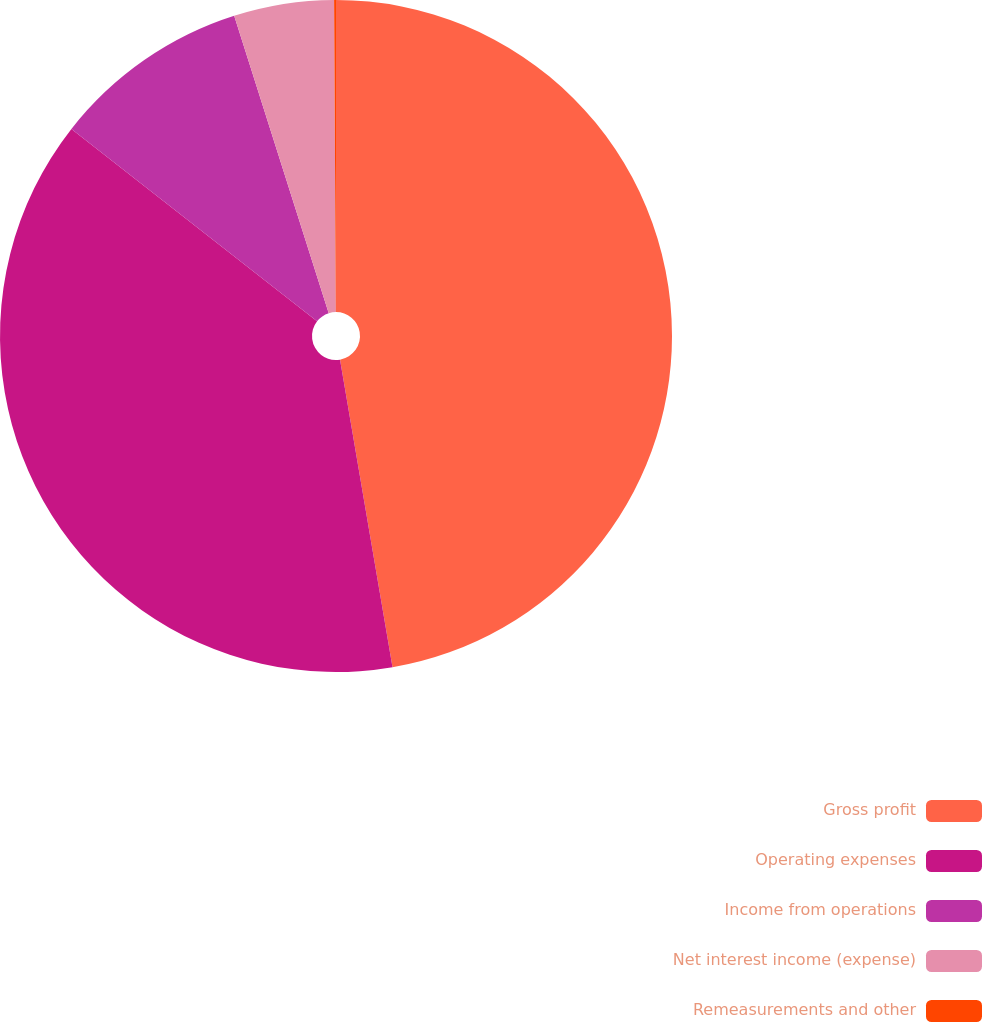<chart> <loc_0><loc_0><loc_500><loc_500><pie_chart><fcel>Gross profit<fcel>Operating expenses<fcel>Income from operations<fcel>Net interest income (expense)<fcel>Remeasurements and other<nl><fcel>47.31%<fcel>38.26%<fcel>9.53%<fcel>4.81%<fcel>0.09%<nl></chart> 